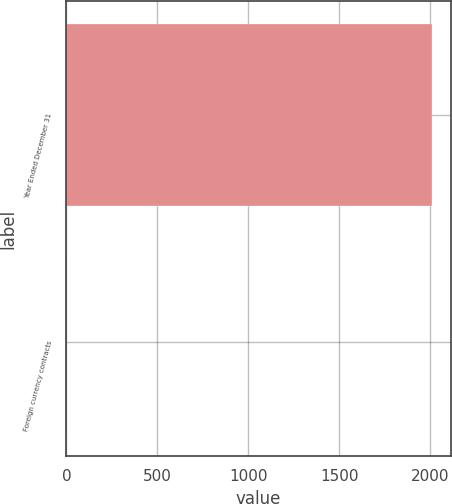Convert chart to OTSL. <chart><loc_0><loc_0><loc_500><loc_500><bar_chart><fcel>Year Ended December 31<fcel>Foreign currency contracts<nl><fcel>2011<fcel>3<nl></chart> 